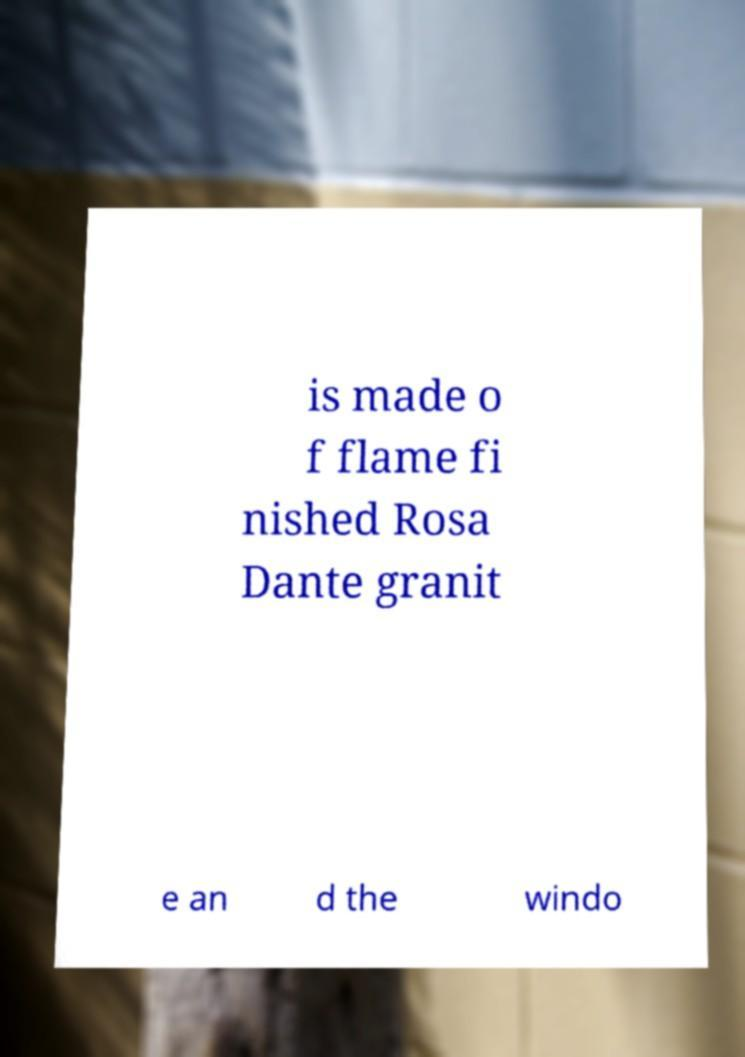Please identify and transcribe the text found in this image. is made o f flame fi nished Rosa Dante granit e an d the windo 